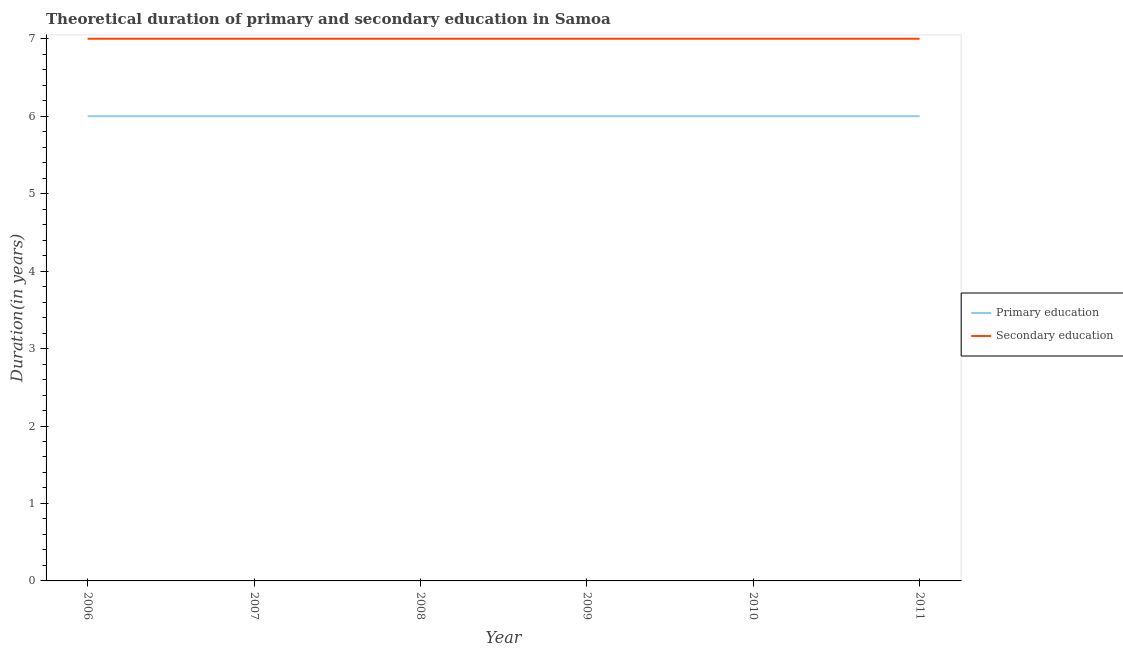How many different coloured lines are there?
Ensure brevity in your answer.  2. Does the line corresponding to duration of primary education intersect with the line corresponding to duration of secondary education?
Give a very brief answer. No. Across all years, what is the minimum duration of secondary education?
Provide a succinct answer. 7. In which year was the duration of primary education maximum?
Keep it short and to the point. 2006. In which year was the duration of secondary education minimum?
Your answer should be compact. 2006. What is the total duration of secondary education in the graph?
Offer a terse response. 42. What is the difference between the duration of primary education in 2008 and that in 2009?
Provide a short and direct response. 0. What is the difference between the duration of secondary education in 2011 and the duration of primary education in 2006?
Make the answer very short. 1. In the year 2010, what is the difference between the duration of primary education and duration of secondary education?
Your answer should be compact. -1. In how many years, is the duration of secondary education greater than 3.2 years?
Ensure brevity in your answer.  6. What is the difference between the highest and the second highest duration of primary education?
Your answer should be compact. 0. What is the difference between the highest and the lowest duration of secondary education?
Your response must be concise. 0. In how many years, is the duration of secondary education greater than the average duration of secondary education taken over all years?
Your answer should be compact. 0. How many lines are there?
Your response must be concise. 2. What is the difference between two consecutive major ticks on the Y-axis?
Provide a short and direct response. 1. Are the values on the major ticks of Y-axis written in scientific E-notation?
Offer a terse response. No. Does the graph contain any zero values?
Make the answer very short. No. Does the graph contain grids?
Make the answer very short. No. How are the legend labels stacked?
Provide a succinct answer. Vertical. What is the title of the graph?
Offer a terse response. Theoretical duration of primary and secondary education in Samoa. What is the label or title of the Y-axis?
Offer a very short reply. Duration(in years). What is the Duration(in years) in Primary education in 2007?
Provide a succinct answer. 6. What is the Duration(in years) in Secondary education in 2007?
Your response must be concise. 7. What is the Duration(in years) of Primary education in 2008?
Ensure brevity in your answer.  6. What is the Duration(in years) in Primary education in 2009?
Your answer should be compact. 6. What is the Duration(in years) of Secondary education in 2009?
Offer a terse response. 7. Across all years, what is the maximum Duration(in years) of Primary education?
Your answer should be very brief. 6. Across all years, what is the maximum Duration(in years) in Secondary education?
Keep it short and to the point. 7. Across all years, what is the minimum Duration(in years) of Secondary education?
Make the answer very short. 7. What is the total Duration(in years) of Secondary education in the graph?
Offer a terse response. 42. What is the difference between the Duration(in years) in Primary education in 2006 and that in 2008?
Keep it short and to the point. 0. What is the difference between the Duration(in years) of Secondary education in 2006 and that in 2008?
Ensure brevity in your answer.  0. What is the difference between the Duration(in years) in Primary education in 2006 and that in 2009?
Provide a short and direct response. 0. What is the difference between the Duration(in years) in Secondary education in 2006 and that in 2010?
Provide a succinct answer. 0. What is the difference between the Duration(in years) in Primary education in 2006 and that in 2011?
Your answer should be very brief. 0. What is the difference between the Duration(in years) in Secondary education in 2006 and that in 2011?
Offer a terse response. 0. What is the difference between the Duration(in years) in Primary education in 2007 and that in 2008?
Make the answer very short. 0. What is the difference between the Duration(in years) in Secondary education in 2007 and that in 2008?
Ensure brevity in your answer.  0. What is the difference between the Duration(in years) in Secondary education in 2007 and that in 2009?
Give a very brief answer. 0. What is the difference between the Duration(in years) in Secondary education in 2008 and that in 2009?
Your response must be concise. 0. What is the difference between the Duration(in years) of Primary education in 2008 and that in 2010?
Your answer should be compact. 0. What is the difference between the Duration(in years) in Secondary education in 2008 and that in 2010?
Your response must be concise. 0. What is the difference between the Duration(in years) of Primary education in 2008 and that in 2011?
Keep it short and to the point. 0. What is the difference between the Duration(in years) in Secondary education in 2009 and that in 2010?
Make the answer very short. 0. What is the difference between the Duration(in years) of Secondary education in 2009 and that in 2011?
Ensure brevity in your answer.  0. What is the difference between the Duration(in years) of Primary education in 2010 and that in 2011?
Make the answer very short. 0. What is the difference between the Duration(in years) in Secondary education in 2010 and that in 2011?
Your answer should be compact. 0. What is the difference between the Duration(in years) of Primary education in 2006 and the Duration(in years) of Secondary education in 2009?
Offer a very short reply. -1. What is the difference between the Duration(in years) in Primary education in 2006 and the Duration(in years) in Secondary education in 2010?
Your answer should be very brief. -1. What is the difference between the Duration(in years) of Primary education in 2007 and the Duration(in years) of Secondary education in 2009?
Give a very brief answer. -1. What is the difference between the Duration(in years) in Primary education in 2007 and the Duration(in years) in Secondary education in 2010?
Make the answer very short. -1. What is the difference between the Duration(in years) in Primary education in 2008 and the Duration(in years) in Secondary education in 2009?
Keep it short and to the point. -1. What is the difference between the Duration(in years) in Primary education in 2008 and the Duration(in years) in Secondary education in 2010?
Offer a terse response. -1. What is the difference between the Duration(in years) of Primary education in 2008 and the Duration(in years) of Secondary education in 2011?
Your answer should be compact. -1. What is the difference between the Duration(in years) in Primary education in 2009 and the Duration(in years) in Secondary education in 2011?
Your answer should be very brief. -1. What is the difference between the Duration(in years) in Primary education in 2010 and the Duration(in years) in Secondary education in 2011?
Ensure brevity in your answer.  -1. What is the average Duration(in years) of Primary education per year?
Your response must be concise. 6. In the year 2009, what is the difference between the Duration(in years) in Primary education and Duration(in years) in Secondary education?
Offer a very short reply. -1. In the year 2010, what is the difference between the Duration(in years) of Primary education and Duration(in years) of Secondary education?
Provide a short and direct response. -1. What is the ratio of the Duration(in years) of Primary education in 2006 to that in 2007?
Keep it short and to the point. 1. What is the ratio of the Duration(in years) in Primary education in 2006 to that in 2008?
Your response must be concise. 1. What is the ratio of the Duration(in years) of Primary education in 2006 to that in 2010?
Give a very brief answer. 1. What is the ratio of the Duration(in years) in Primary education in 2006 to that in 2011?
Ensure brevity in your answer.  1. What is the ratio of the Duration(in years) in Secondary education in 2006 to that in 2011?
Ensure brevity in your answer.  1. What is the ratio of the Duration(in years) of Secondary education in 2007 to that in 2008?
Your answer should be compact. 1. What is the ratio of the Duration(in years) in Primary education in 2007 to that in 2010?
Offer a very short reply. 1. What is the ratio of the Duration(in years) in Secondary education in 2007 to that in 2011?
Ensure brevity in your answer.  1. What is the ratio of the Duration(in years) of Primary education in 2008 to that in 2009?
Make the answer very short. 1. What is the ratio of the Duration(in years) of Secondary education in 2008 to that in 2009?
Your answer should be compact. 1. What is the ratio of the Duration(in years) of Primary education in 2008 to that in 2010?
Provide a succinct answer. 1. What is the ratio of the Duration(in years) in Primary education in 2009 to that in 2010?
Offer a very short reply. 1. What is the ratio of the Duration(in years) of Secondary education in 2009 to that in 2010?
Provide a short and direct response. 1. What is the ratio of the Duration(in years) of Primary education in 2009 to that in 2011?
Your response must be concise. 1. What is the ratio of the Duration(in years) of Primary education in 2010 to that in 2011?
Ensure brevity in your answer.  1. What is the difference between the highest and the second highest Duration(in years) of Primary education?
Provide a succinct answer. 0. What is the difference between the highest and the second highest Duration(in years) of Secondary education?
Provide a succinct answer. 0. What is the difference between the highest and the lowest Duration(in years) of Primary education?
Make the answer very short. 0. 